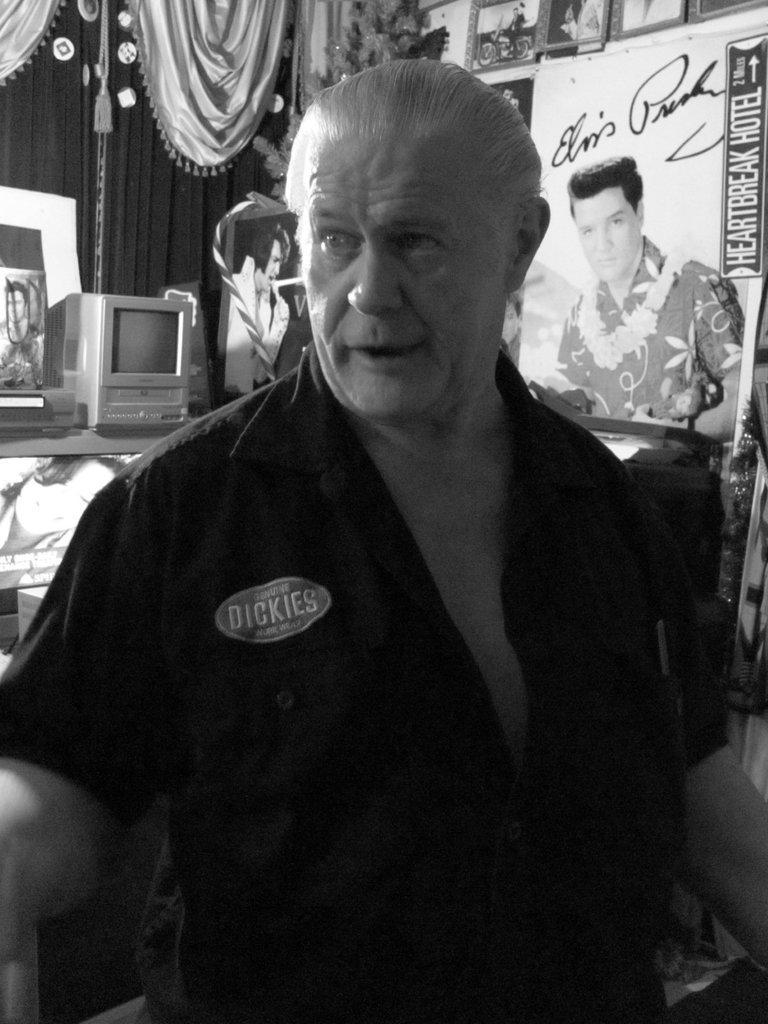Can you describe this image briefly? This image consists of a man wearing a black shirt. On the left, there is a computer. And we can see a curtain. In the background, there are many frames. 